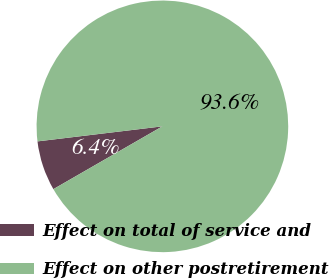Convert chart to OTSL. <chart><loc_0><loc_0><loc_500><loc_500><pie_chart><fcel>Effect on total of service and<fcel>Effect on other postretirement<nl><fcel>6.41%<fcel>93.59%<nl></chart> 